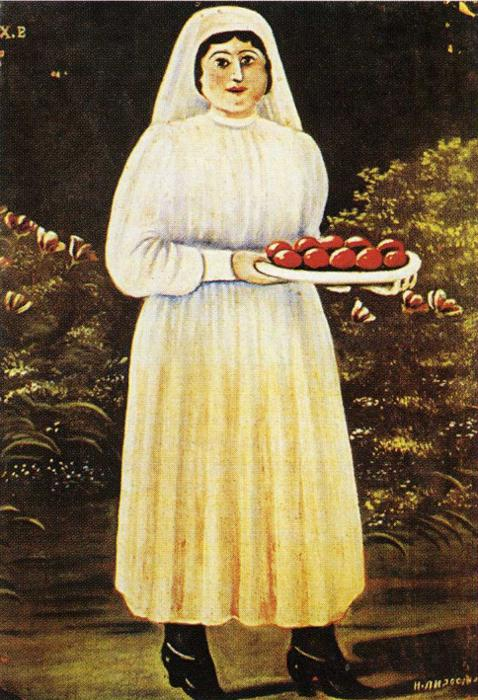What is this photo about'? The image presents a painting created in a folk art style. It features a central figure, a woman donning a white dress and headscarf, standing against a dark background. She holds a tray brimming with red apples, hinting at themes of harvest or abundance. A tree behind her, decorated with red flowers and green leaves, adds a splash of vivid color to the dark setting. The painting is signed 'H.H. 26/6' in the bottom right corner, perhaps indicating the artist's initials and the date of creation. The juxtaposition of bright colors with a dark backdrop and the simplicity of the forms and figures are hallmarks of folk art. The composition evokes a sense of tranquility and harmony. 